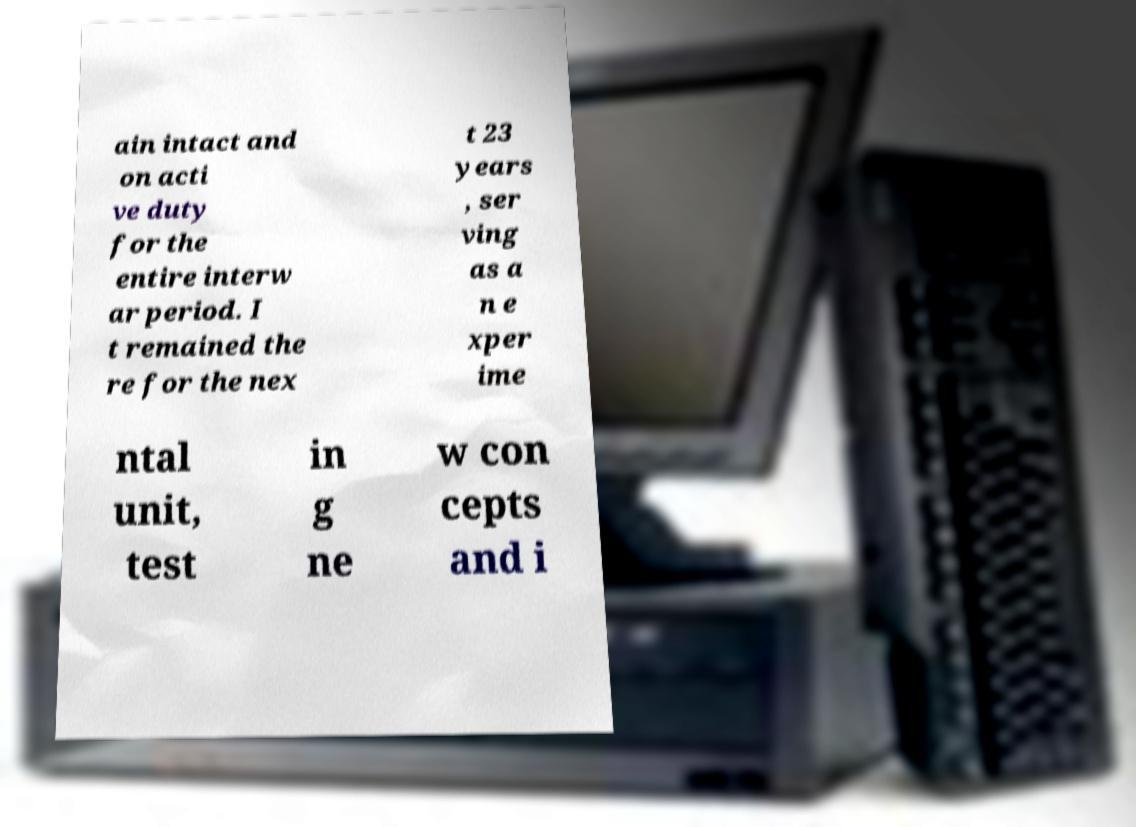Can you accurately transcribe the text from the provided image for me? ain intact and on acti ve duty for the entire interw ar period. I t remained the re for the nex t 23 years , ser ving as a n e xper ime ntal unit, test in g ne w con cepts and i 